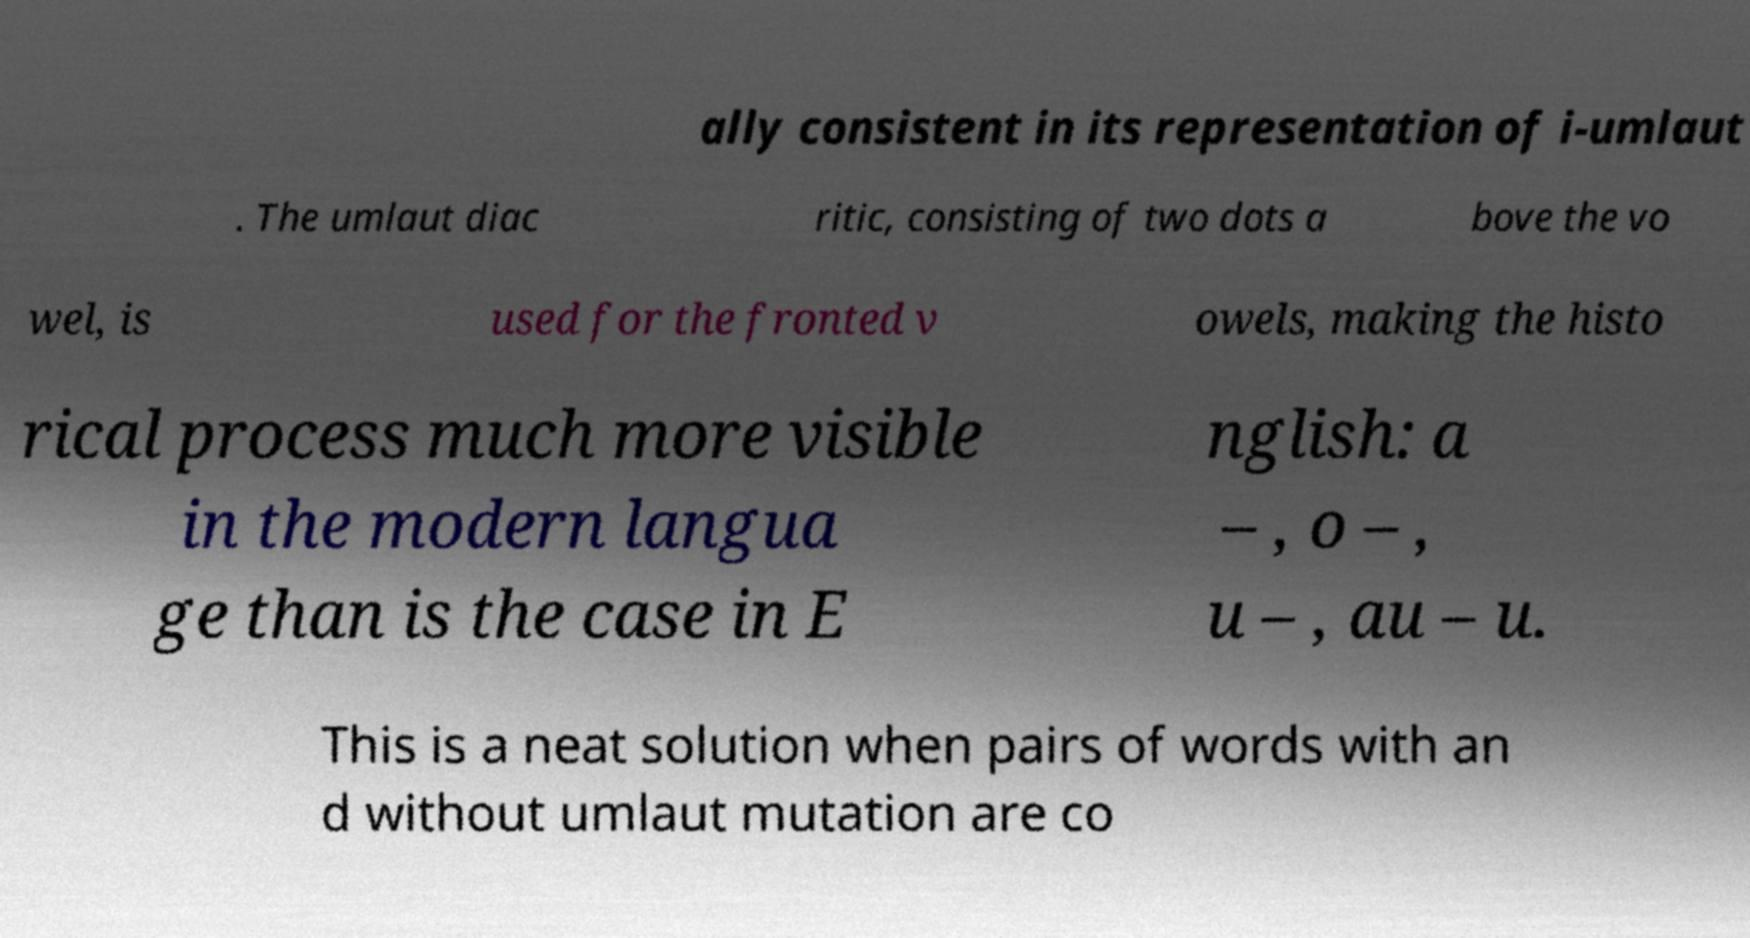Could you extract and type out the text from this image? ally consistent in its representation of i-umlaut . The umlaut diac ritic, consisting of two dots a bove the vo wel, is used for the fronted v owels, making the histo rical process much more visible in the modern langua ge than is the case in E nglish: a – , o – , u – , au – u. This is a neat solution when pairs of words with an d without umlaut mutation are co 